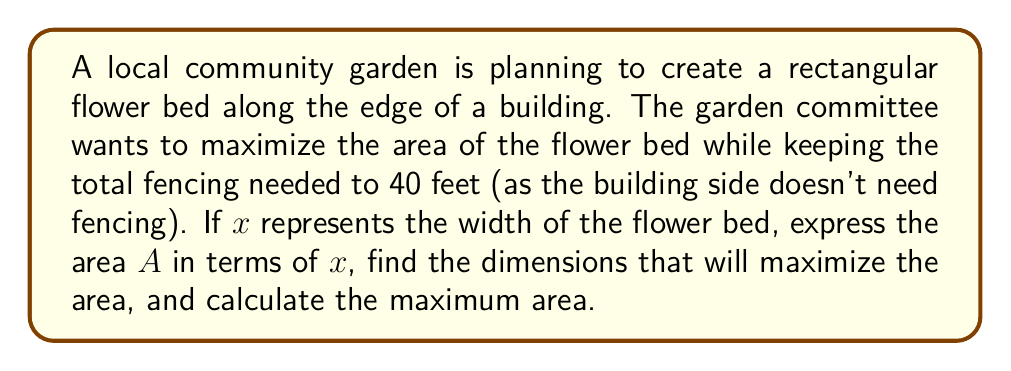Give your solution to this math problem. Let's approach this step-by-step:

1) Let x be the width of the flower bed, and y be the length.

2) We know that the perimeter minus one side (the building side) is 40 feet:
   $$ 2x + y = 40 $$

3) Solve this equation for y:
   $$ y = 40 - 2x $$

4) The area of a rectangle is given by A = xy. Substituting our expression for y:
   $$ A = x(40 - 2x) = 40x - 2x^2 $$

5) This is our quadratic function for the area. To find the maximum, we need to find the vertex of this parabola.

6) For a quadratic function in the form $f(x) = ax^2 + bx + c$, the x-coordinate of the vertex is given by $x = -\frac{b}{2a}$.

7) In our case, $a = -2$, $b = 40$, and $c = 0$. So:
   $$ x = -\frac{40}{2(-2)} = 10 $$

8) To find y, we substitute x = 10 into our equation from step 3:
   $$ y = 40 - 2(10) = 20 $$

9) To find the maximum area, we substitute x = 10 into our area function:
   $$ A = 40(10) - 2(10)^2 = 400 - 200 = 200 $$

Therefore, the dimensions that maximize the area are 10 feet by 20 feet, and the maximum area is 200 square feet.
Answer: The dimensions that maximize the area are 10 feet wide by 20 feet long, with a maximum area of 200 square feet. 